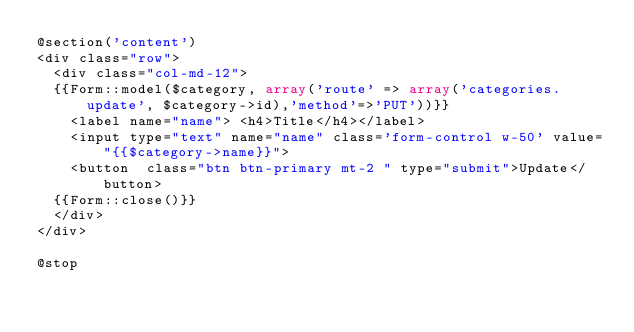Convert code to text. <code><loc_0><loc_0><loc_500><loc_500><_PHP_>@section('content')
<div class="row">
	<div class="col-md-12">
	{{Form::model($category, array('route' => array('categories.update', $category->id),'method'=>'PUT'))}}
		<label name="name">	<h4>Title</h4></label>	
		<input type="text" name="name" class='form-control w-50' value="{{$category->name}}">
		<button  class="btn btn-primary mt-2 " type="submit">Update</button>
	{{Form::close()}}
	</div>	
</div>

@stop</code> 